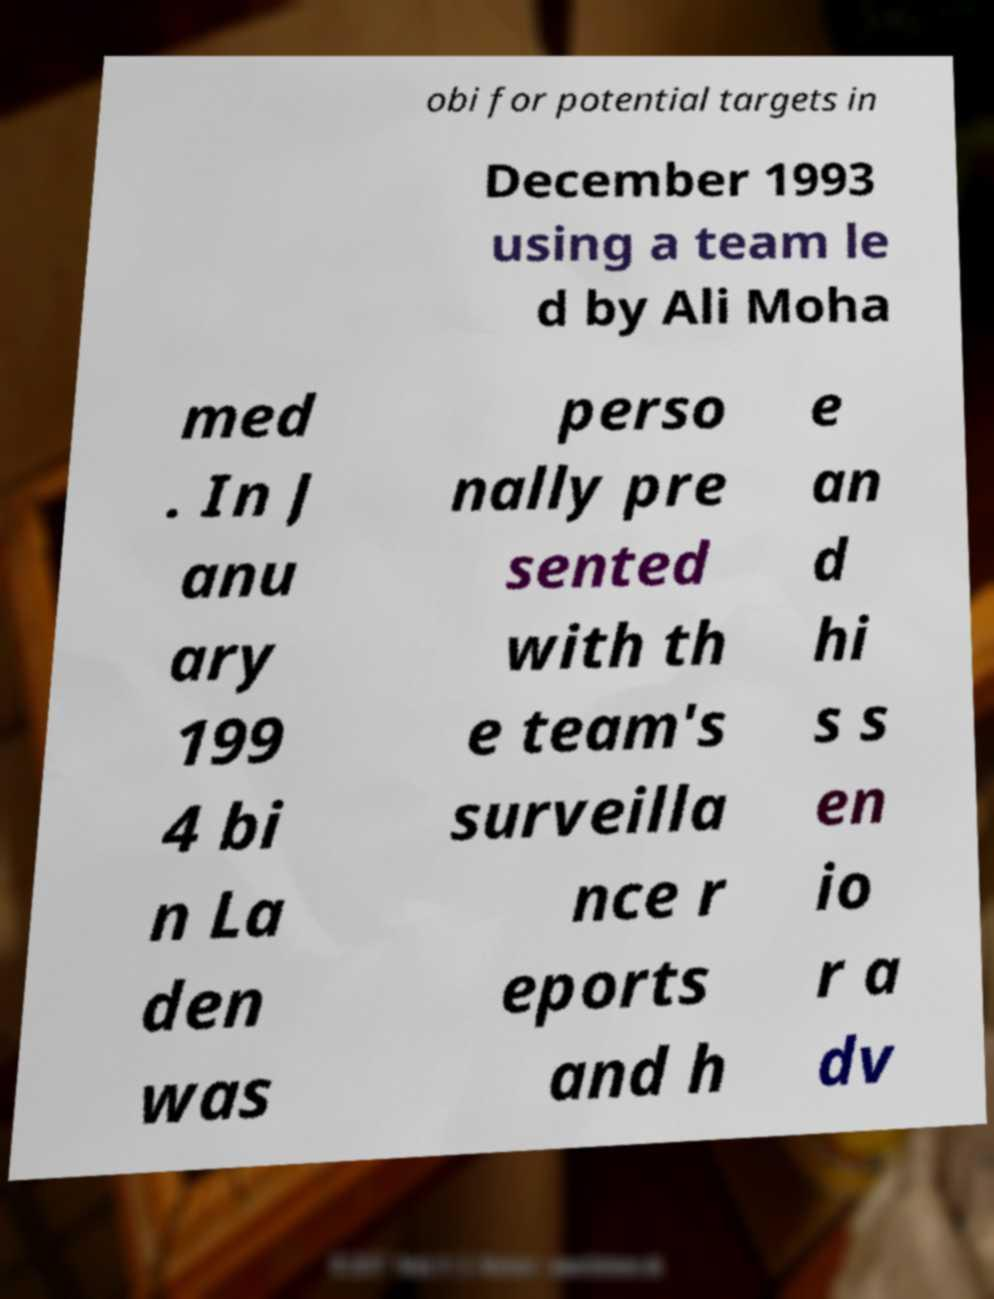I need the written content from this picture converted into text. Can you do that? obi for potential targets in December 1993 using a team le d by Ali Moha med . In J anu ary 199 4 bi n La den was perso nally pre sented with th e team's surveilla nce r eports and h e an d hi s s en io r a dv 